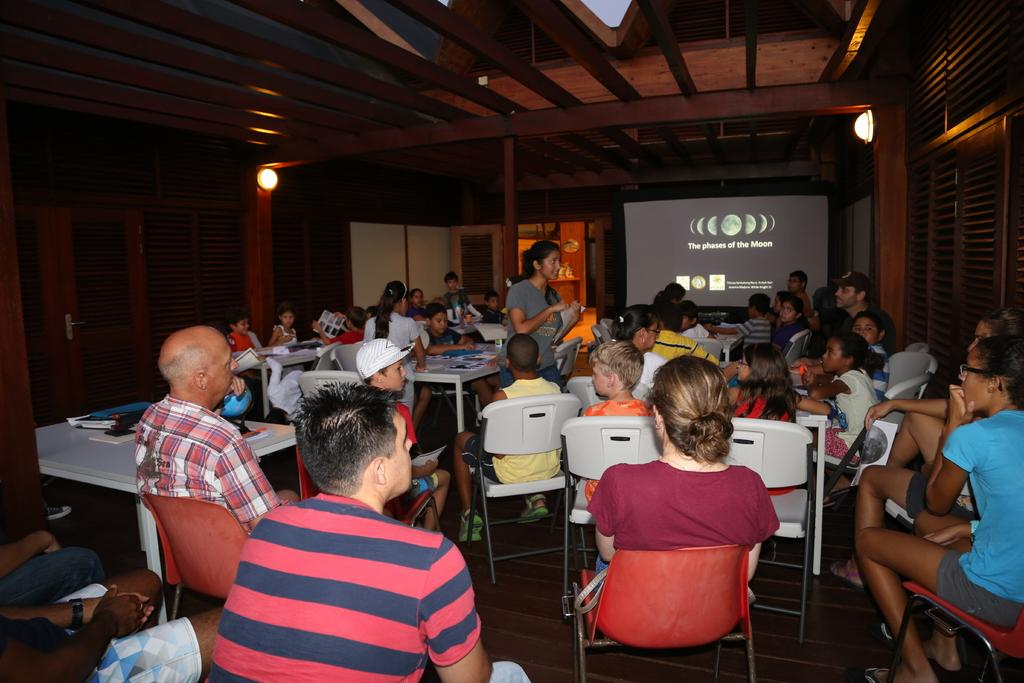How many people are present in the image? There are many people in the image. What are the people doing in the image? The people are sitting on chairs. What is located at the front of the room? There is a projector screen in the front of the room. What type of event might be taking place in the image? The scene appears to be a parents-teachers meeting. What type of treatment is being administered to the grandmother in the image? There is no grandmother or treatment present in the image. 